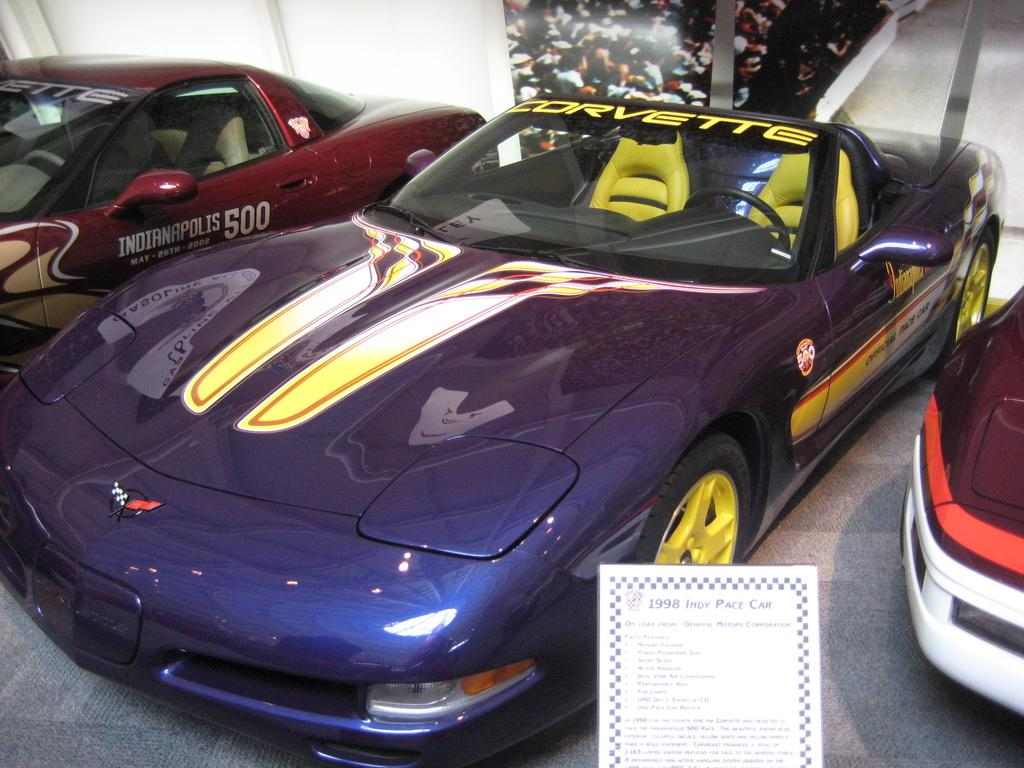What type of vehicles can be seen in the image? There are cars in the image. What is visible beneath the cars in the image? The ground is visible in the image. What is attached to the wall in the image? There is a poster with some text on it in the image. Where is the poster located in the image? The poster is on a wall in the image. What type of teeth can be seen in the frame in the image? There is no frame or teeth present in the image. 